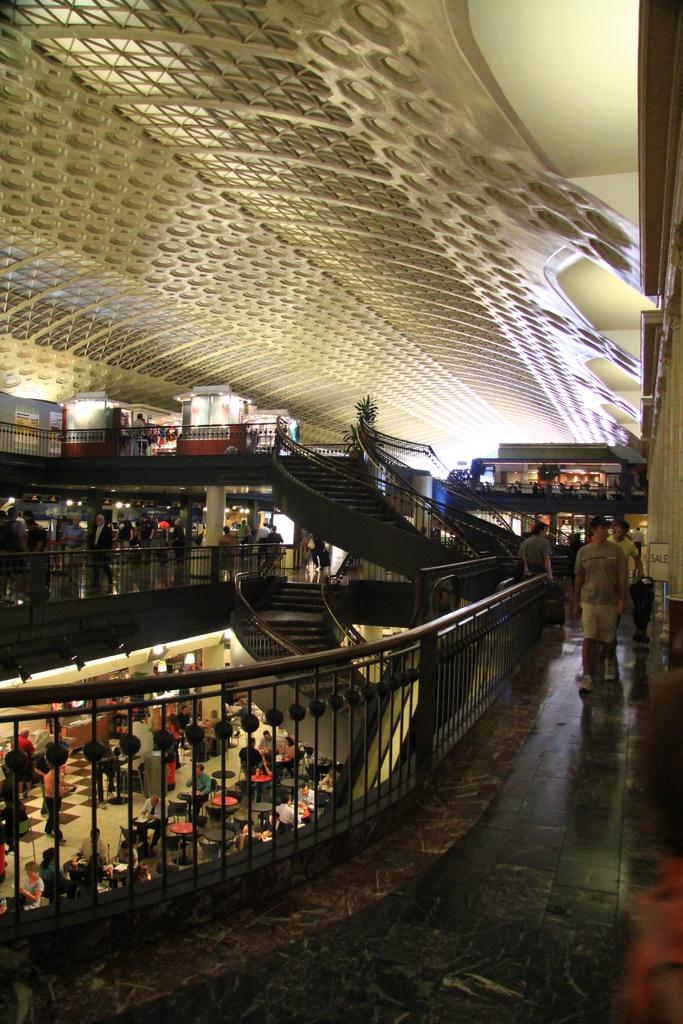What type of location is depicted in the image? The image appears to be an inside view of a mall. What architectural feature can be seen in the image? There are stairs and railings present in the image. What type of greenery is visible in the image? There is a plant in the image. What type of businesses or services might be available in the image? Stalls are visible in the image, which suggests there are various businesses or services available. Are there any people present in the image? Yes, there are people in the image. What is the structure of the building visible in the image? The top of the image features a roof, indicating that it is an enclosed space. How many cobwebs can be seen hanging from the ceiling in the image? There are no cobwebs visible in the image. What type of experience can be gained from visiting the mall in the image? The image does not convey any specific experience; it simply shows a view of the mall's interior. 